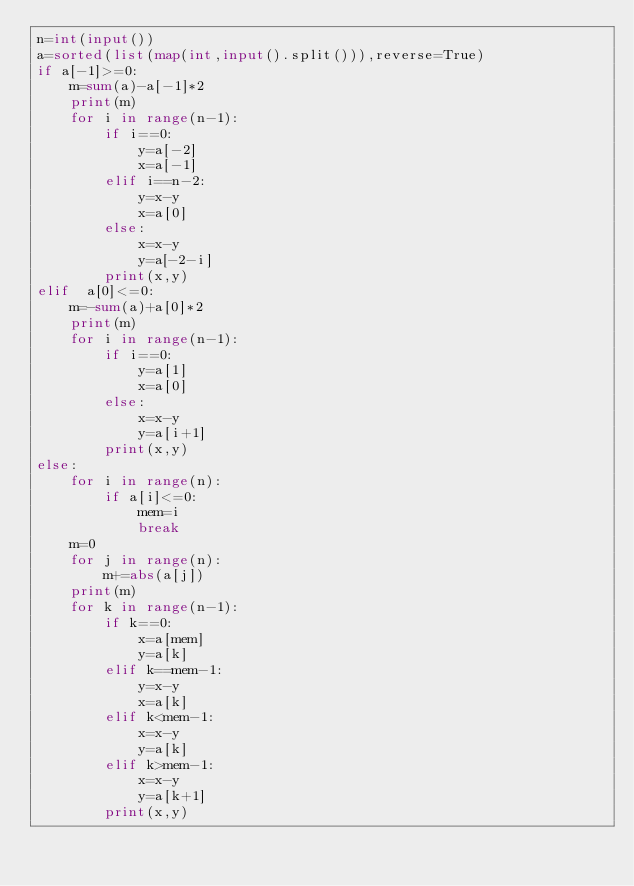Convert code to text. <code><loc_0><loc_0><loc_500><loc_500><_Python_>n=int(input())
a=sorted(list(map(int,input().split())),reverse=True)
if a[-1]>=0:
    m=sum(a)-a[-1]*2
    print(m)
    for i in range(n-1):
        if i==0:
            y=a[-2]
            x=a[-1]
        elif i==n-2:
            y=x-y
            x=a[0]
        else:
            x=x-y
            y=a[-2-i]
        print(x,y)
elif  a[0]<=0:
    m=-sum(a)+a[0]*2
    print(m)
    for i in range(n-1):
        if i==0:
            y=a[1]
            x=a[0]
        else:
            x=x-y
            y=a[i+1]
        print(x,y)
else:
    for i in range(n):
        if a[i]<=0:
            mem=i
            break
    m=0
    for j in range(n):
        m+=abs(a[j])
    print(m)
    for k in range(n-1):
        if k==0:
            x=a[mem]
            y=a[k]
        elif k==mem-1:
            y=x-y
            x=a[k]
        elif k<mem-1:
            x=x-y
            y=a[k]
        elif k>mem-1:
            x=x-y
            y=a[k+1]
        print(x,y)
</code> 